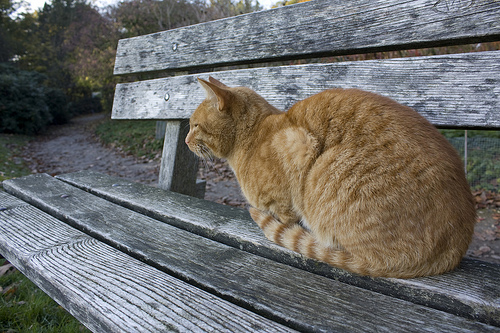Does the bench look gray or maybe red? The bench looks gray in color. 